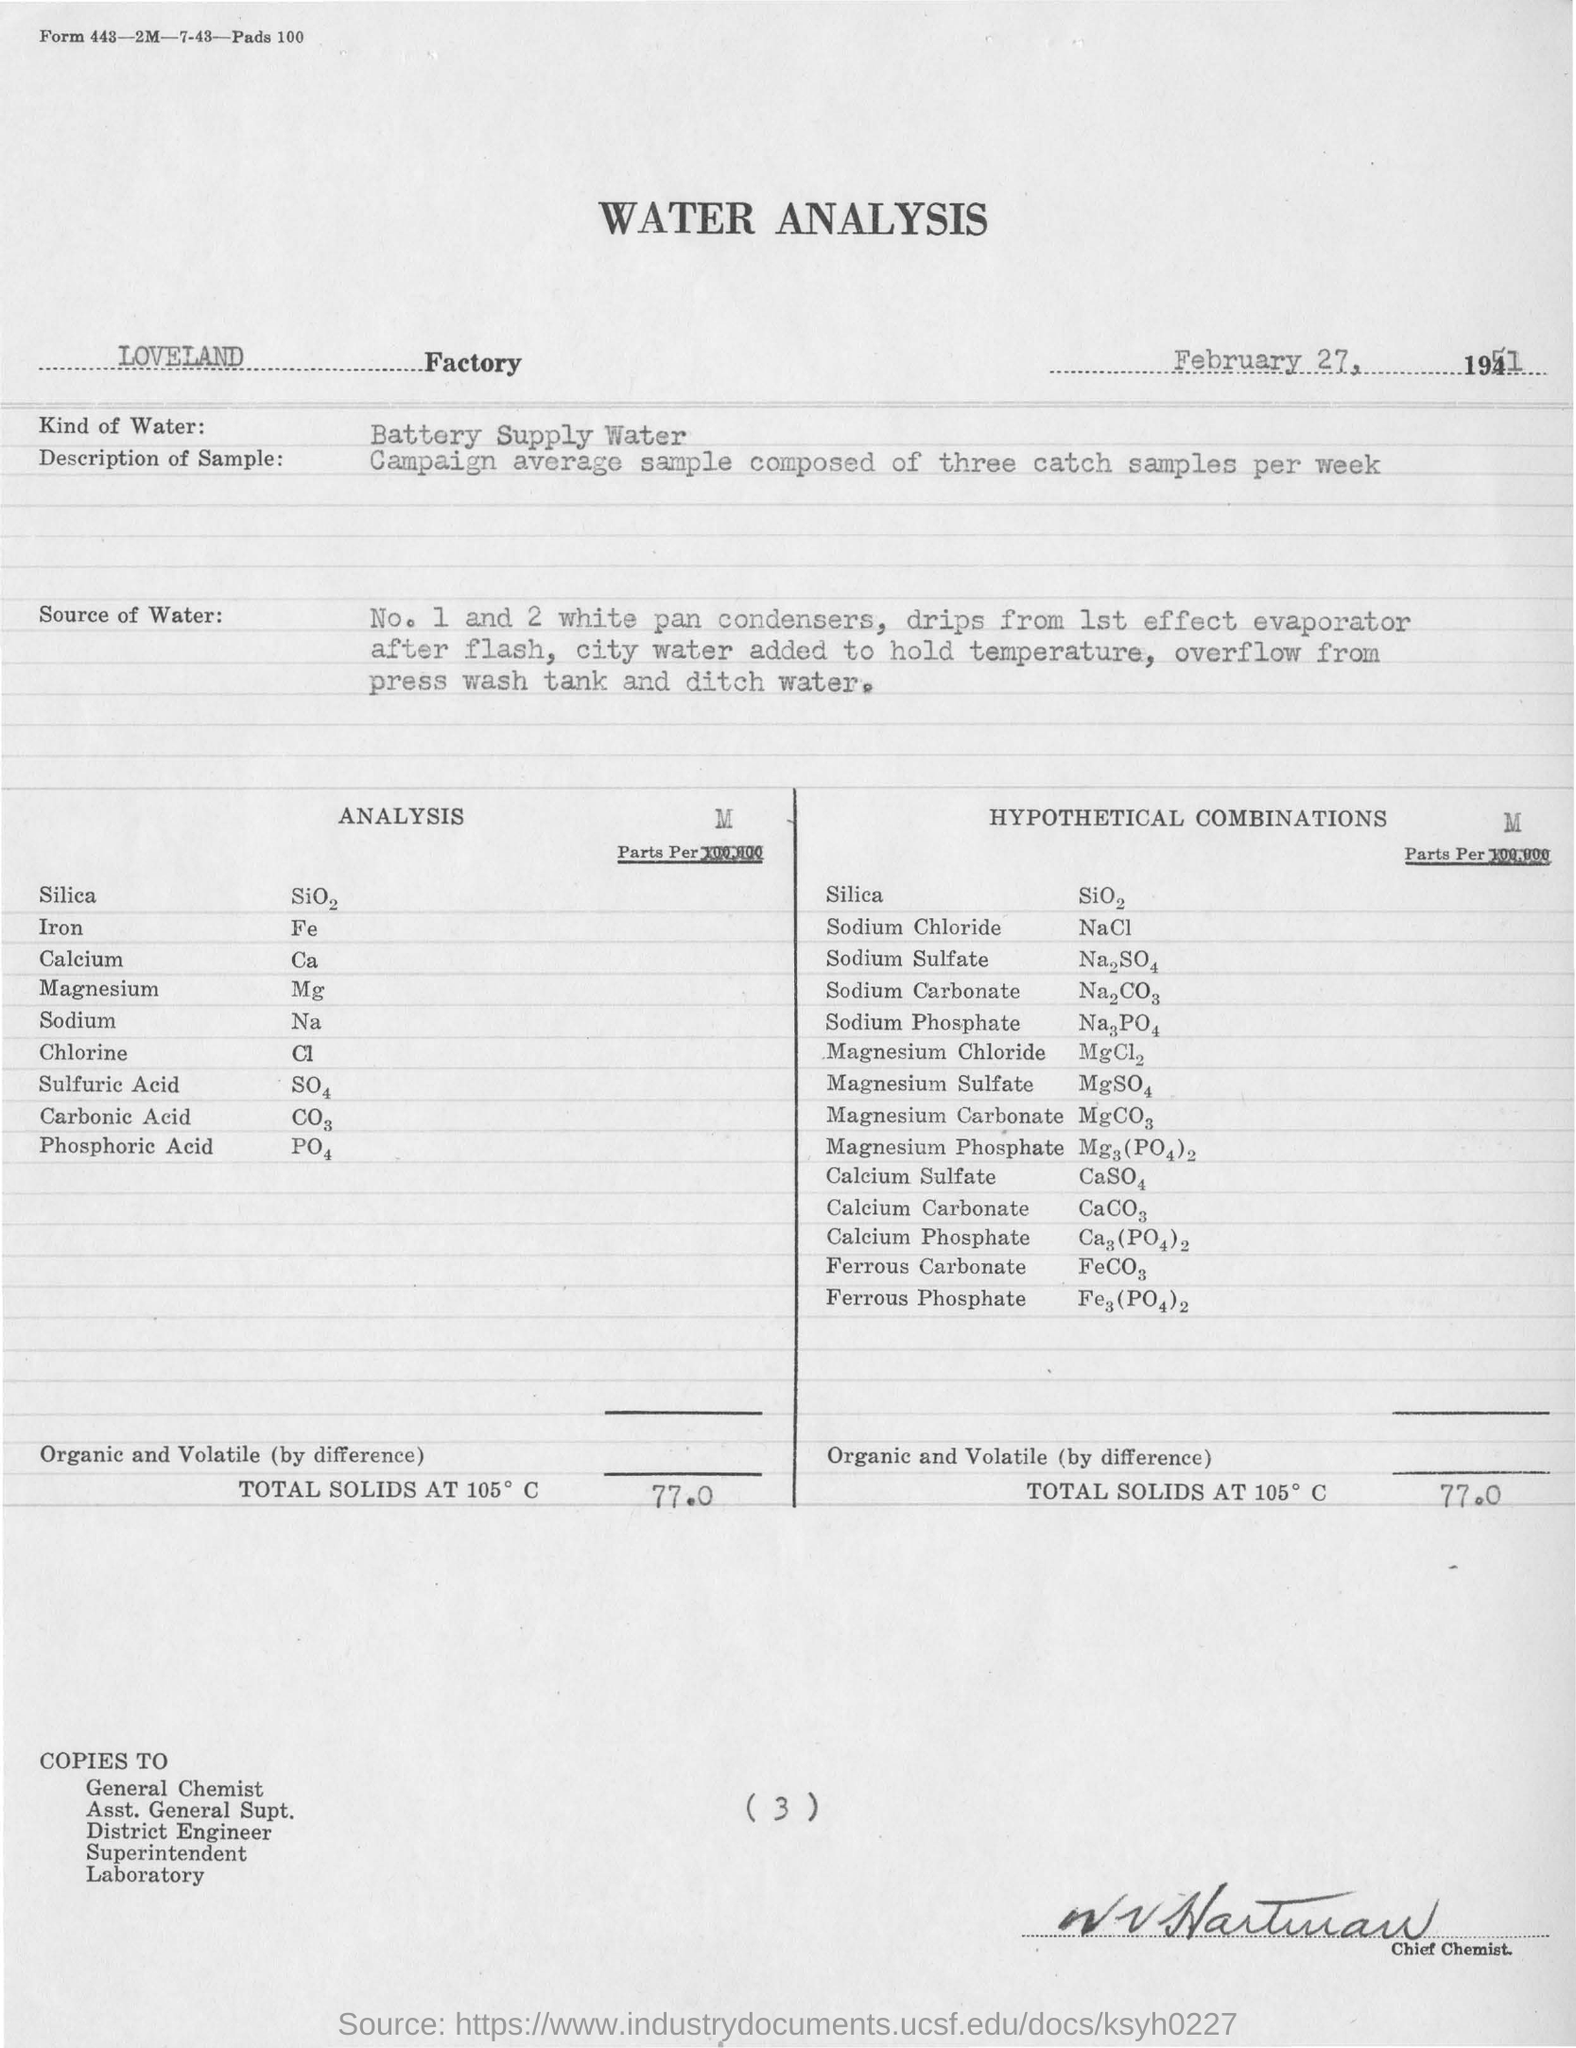Give some essential details in this illustration. The analysis was conducted by the LOVELAND Factory. The total solids measurement is 77.0...". 